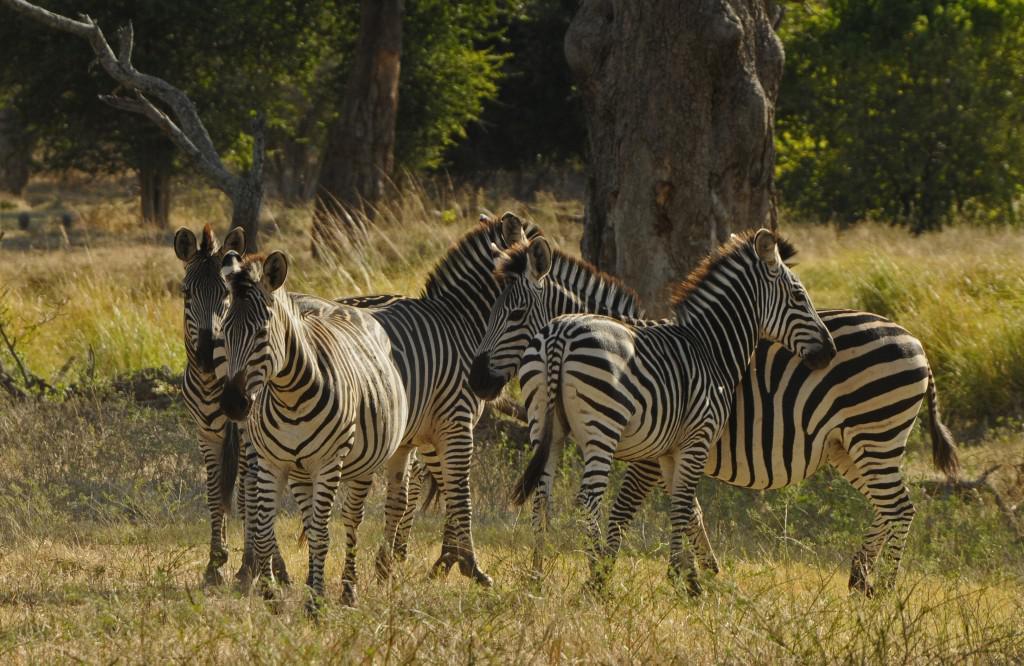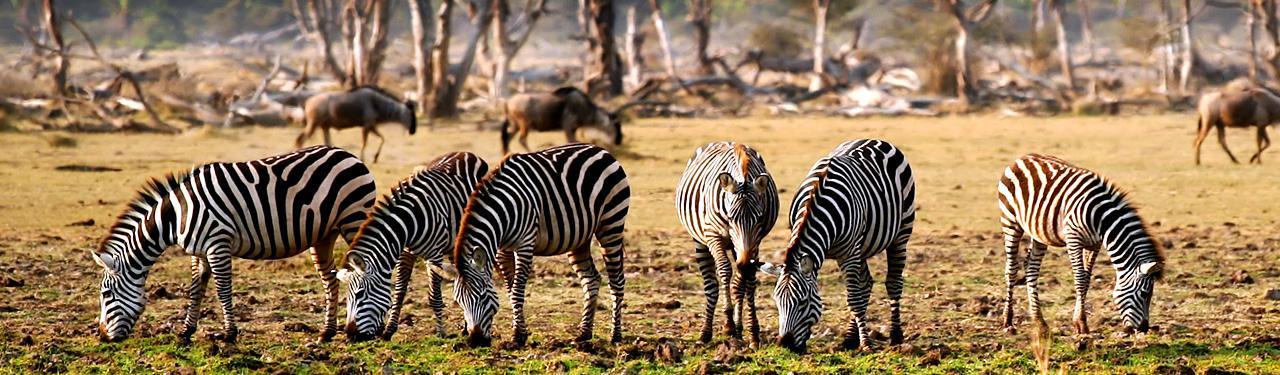The first image is the image on the left, the second image is the image on the right. Examine the images to the left and right. Is the description "In one of the images the zebras are all walking in the same direction." accurate? Answer yes or no. No. The first image is the image on the left, the second image is the image on the right. Evaluate the accuracy of this statement regarding the images: "One image shows zebras standing around grazing, and the other shows zebras that are all walking in one direction.". Is it true? Answer yes or no. No. 